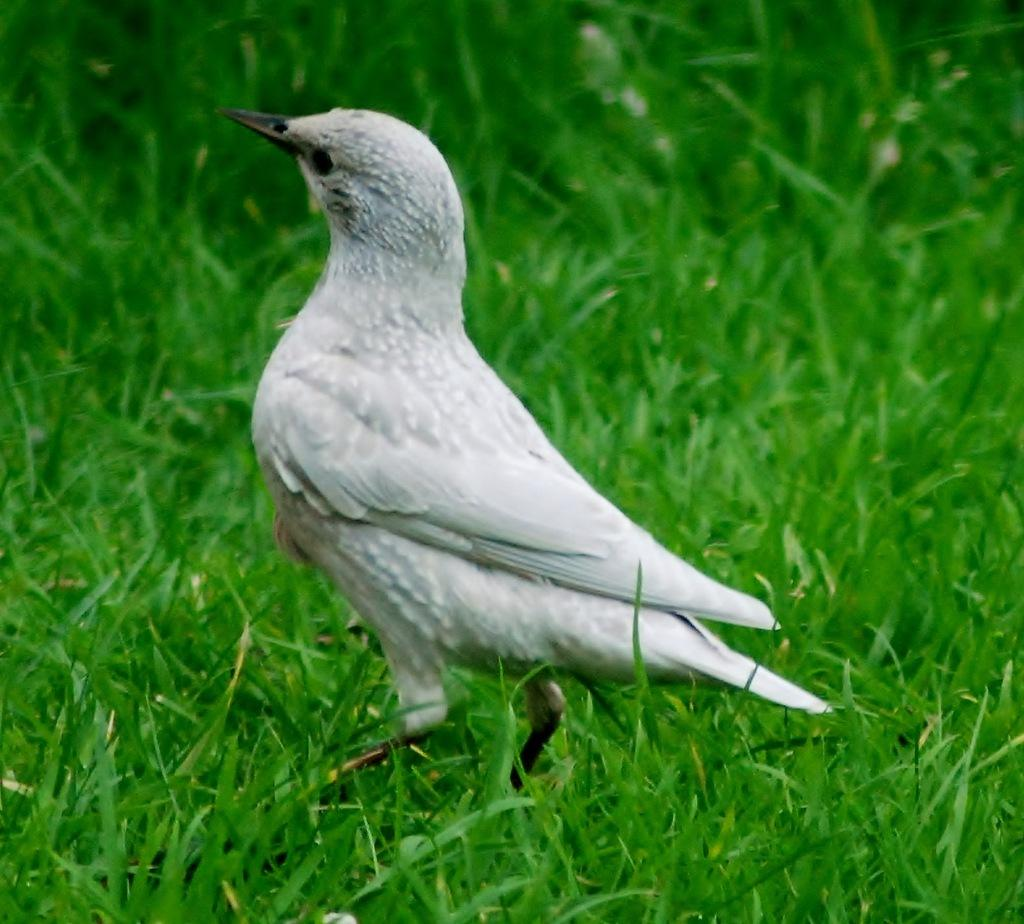What type of animal can be seen in the picture? There is a white-colored bird in the picture. What is the bird standing on? The bird is standing on the grass. What type of shoes is the bird wearing in the picture? Birds do not wear shoes, so there is no mention of shoes in the image. 